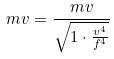<formula> <loc_0><loc_0><loc_500><loc_500>m v = \frac { m v } { \sqrt { 1 \cdot \frac { v ^ { 4 } } { f ^ { 4 } } } }</formula> 